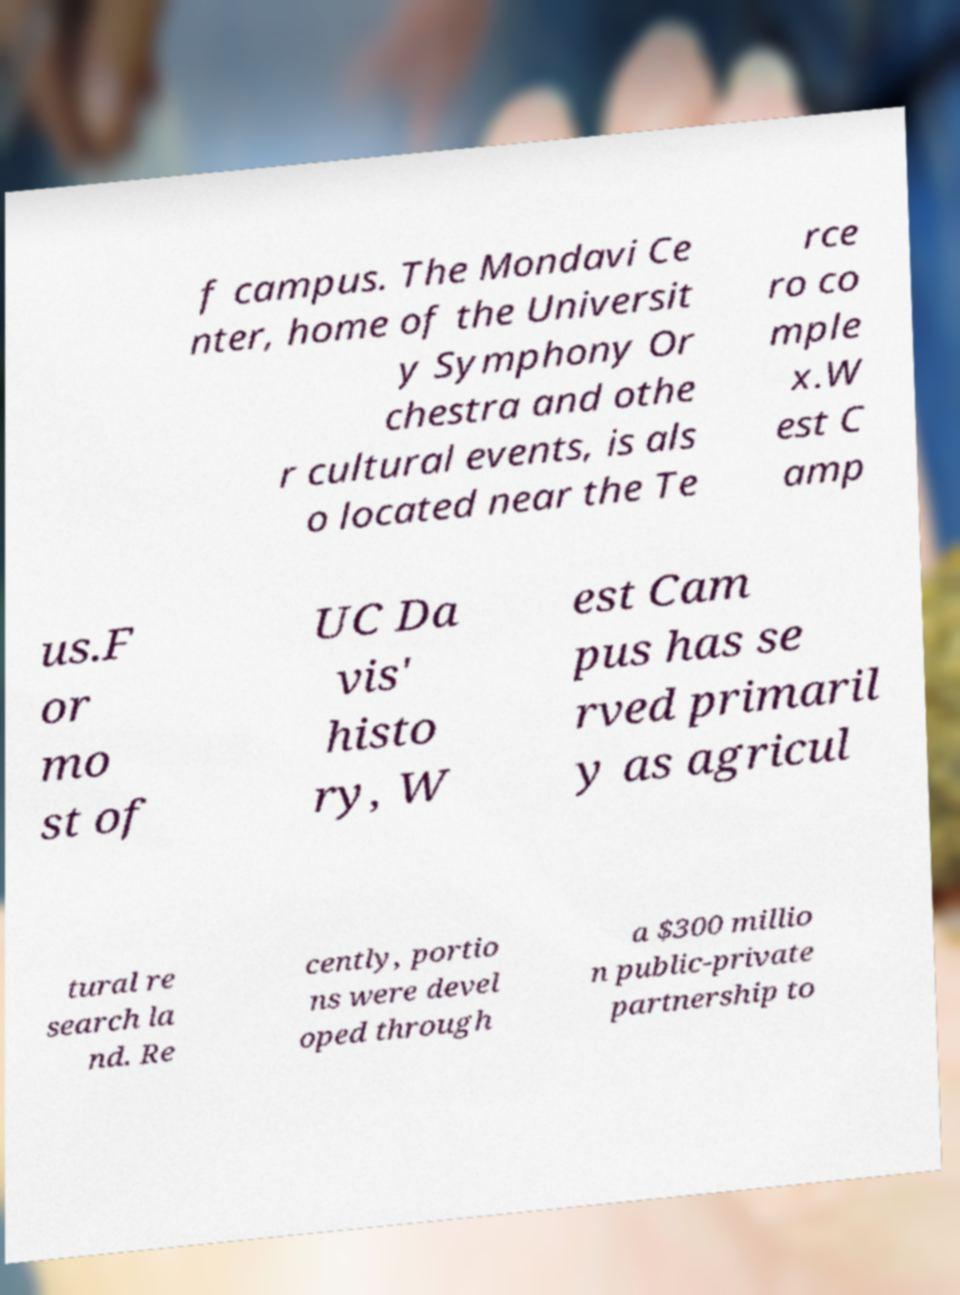I need the written content from this picture converted into text. Can you do that? f campus. The Mondavi Ce nter, home of the Universit y Symphony Or chestra and othe r cultural events, is als o located near the Te rce ro co mple x.W est C amp us.F or mo st of UC Da vis' histo ry, W est Cam pus has se rved primaril y as agricul tural re search la nd. Re cently, portio ns were devel oped through a $300 millio n public-private partnership to 